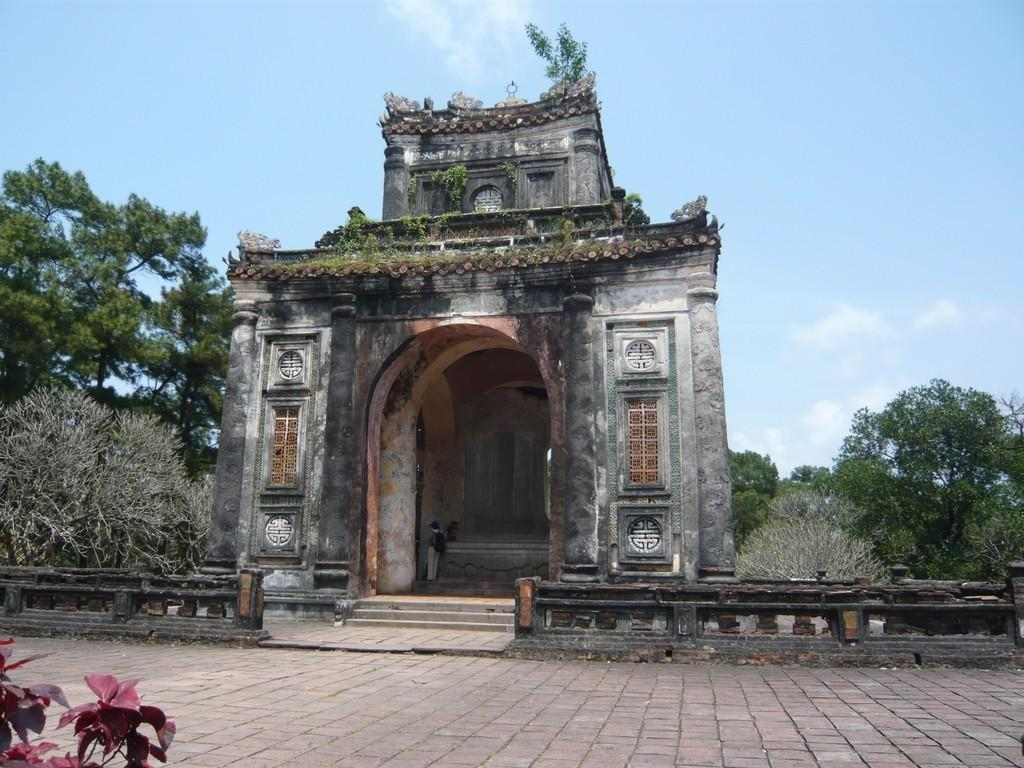What type of structure can be seen in the image? There is a building in the image. What type of barrier is present in the image? There are fences in the image. What type of vegetation is present in the image? Trees are present in the image. What part of the trees can be seen in the image? Leaves are visible in the image. What architectural feature is present in the image? There are steps in the image. What is the person in the image carrying? The person is carrying a bag in the image. Where is the person standing in the image? The person is standing on the ground in the image. What can be seen in the background of the image? The sky is visible in the background of the image. How many cacti are visible in the image? There are no cacti present in the image. What is the boundary between the building and the sky in the image? The image does not show a boundary between the building and the sky; it simply shows the building and the sky in the background. 